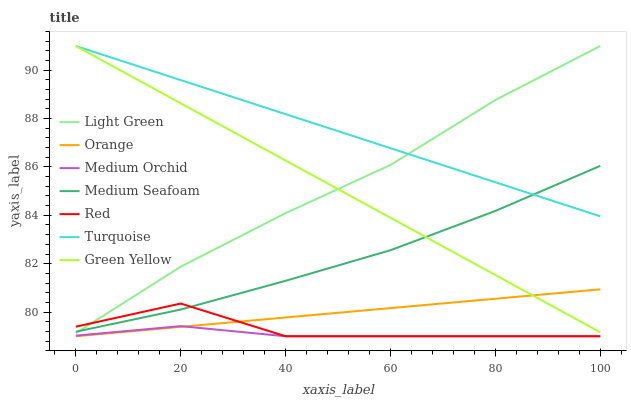Does Medium Orchid have the minimum area under the curve?
Answer yes or no. Yes. Does Turquoise have the maximum area under the curve?
Answer yes or no. Yes. Does Light Green have the minimum area under the curve?
Answer yes or no. No. Does Light Green have the maximum area under the curve?
Answer yes or no. No. Is Turquoise the smoothest?
Answer yes or no. Yes. Is Red the roughest?
Answer yes or no. Yes. Is Medium Orchid the smoothest?
Answer yes or no. No. Is Medium Orchid the roughest?
Answer yes or no. No. Does Medium Orchid have the lowest value?
Answer yes or no. Yes. Does Light Green have the lowest value?
Answer yes or no. No. Does Green Yellow have the highest value?
Answer yes or no. Yes. Does Medium Orchid have the highest value?
Answer yes or no. No. Is Red less than Turquoise?
Answer yes or no. Yes. Is Turquoise greater than Medium Orchid?
Answer yes or no. Yes. Does Medium Seafoam intersect Light Green?
Answer yes or no. Yes. Is Medium Seafoam less than Light Green?
Answer yes or no. No. Is Medium Seafoam greater than Light Green?
Answer yes or no. No. Does Red intersect Turquoise?
Answer yes or no. No. 